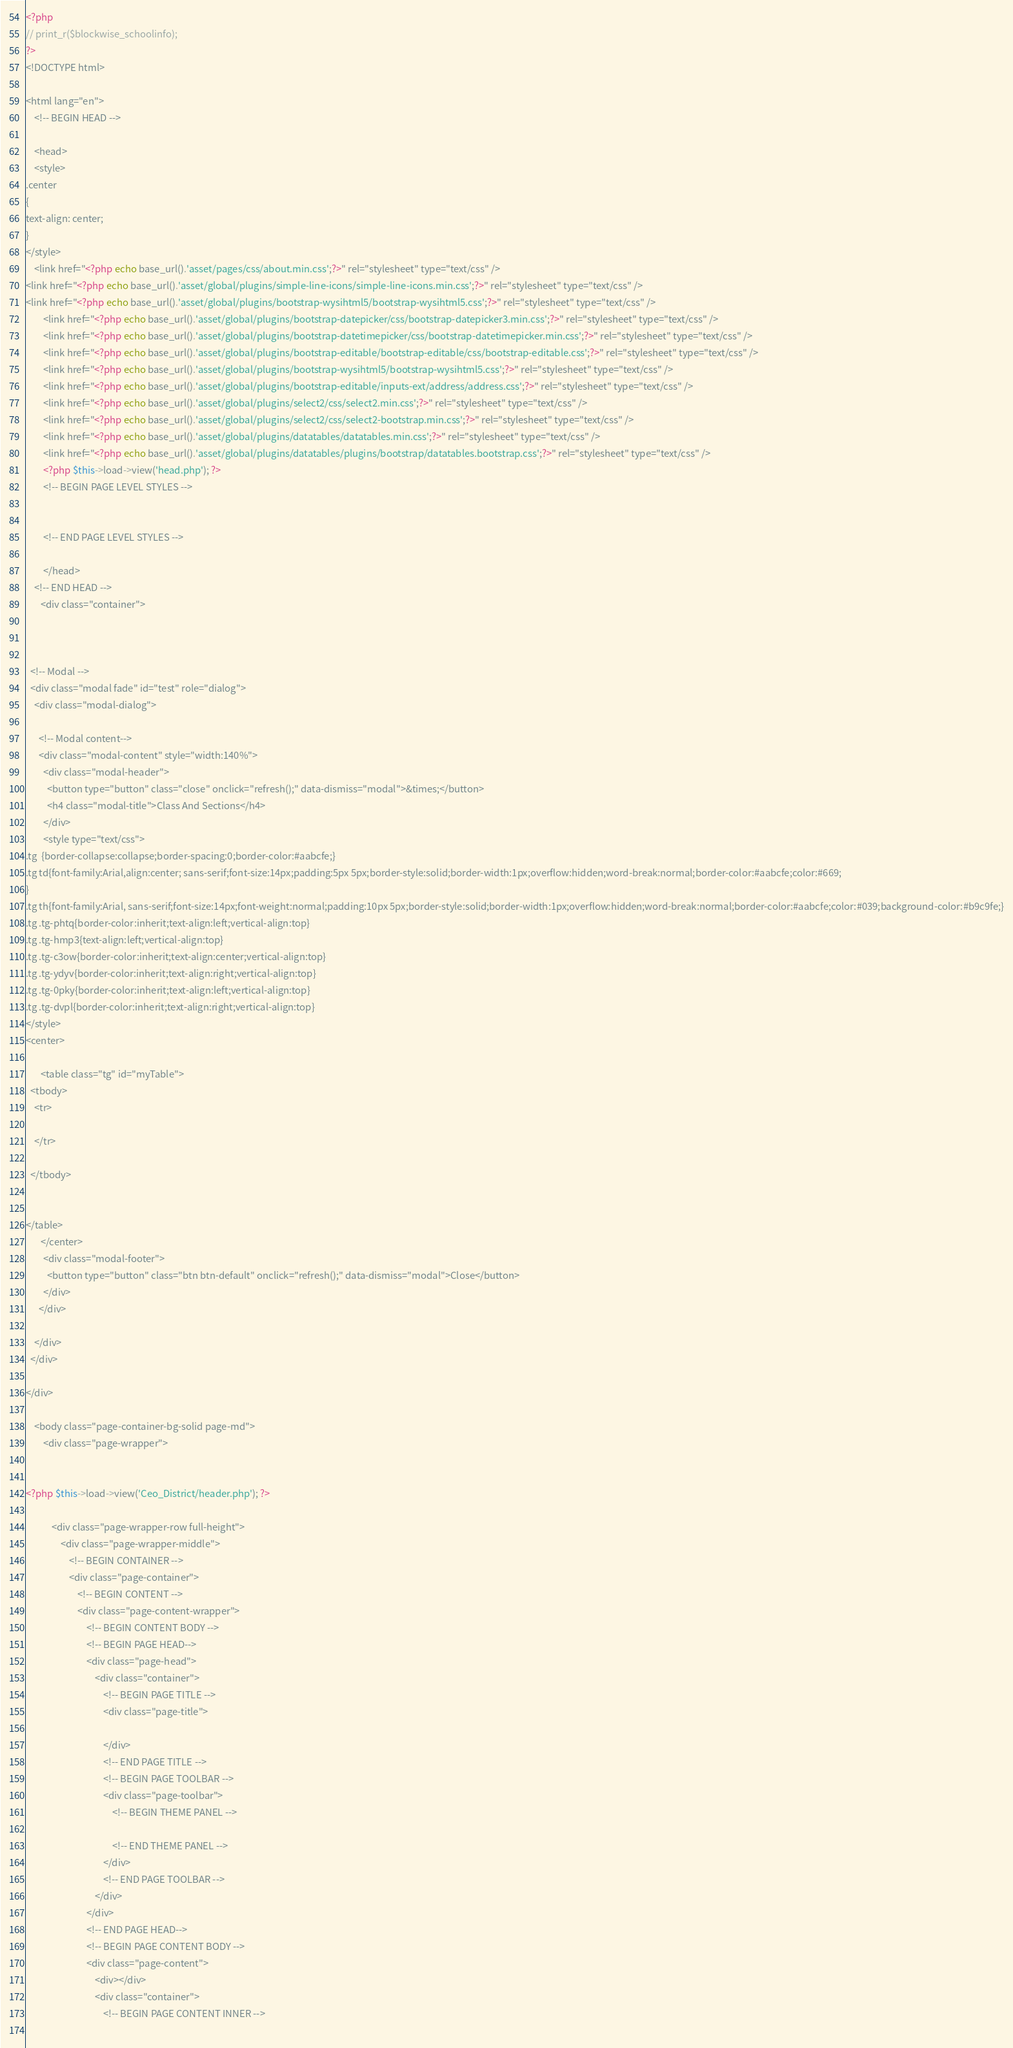Convert code to text. <code><loc_0><loc_0><loc_500><loc_500><_PHP_>

<?php 
// print_r($blockwise_schoolinfo);
?>
<!DOCTYPE html>

<html lang="en">
    <!-- BEGIN HEAD -->

    <head>
    <style> 
.center 
{
text-align: center;
}   
</style>
    <link href="<?php echo base_url().'asset/pages/css/about.min.css';?>" rel="stylesheet" type="text/css" />
<link href="<?php echo base_url().'asset/global/plugins/simple-line-icons/simple-line-icons.min.css';?>" rel="stylesheet" type="text/css" />
<link href="<?php echo base_url().'asset/global/plugins/bootstrap-wysihtml5/bootstrap-wysihtml5.css';?>" rel="stylesheet" type="text/css" />
        <link href="<?php echo base_url().'asset/global/plugins/bootstrap-datepicker/css/bootstrap-datepicker3.min.css';?>" rel="stylesheet" type="text/css" />
        <link href="<?php echo base_url().'asset/global/plugins/bootstrap-datetimepicker/css/bootstrap-datetimepicker.min.css';?>" rel="stylesheet" type="text/css" />
        <link href="<?php echo base_url().'asset/global/plugins/bootstrap-editable/bootstrap-editable/css/bootstrap-editable.css';?>" rel="stylesheet" type="text/css" />
        <link href="<?php echo base_url().'asset/global/plugins/bootstrap-wysihtml5/bootstrap-wysihtml5.css';?>" rel="stylesheet" type="text/css" />
        <link href="<?php echo base_url().'asset/global/plugins/bootstrap-editable/inputs-ext/address/address.css';?>" rel="stylesheet" type="text/css" />
        <link href="<?php echo base_url().'asset/global/plugins/select2/css/select2.min.css';?>" rel="stylesheet" type="text/css" />
        <link href="<?php echo base_url().'asset/global/plugins/select2/css/select2-bootstrap.min.css';?>" rel="stylesheet" type="text/css" />
        <link href="<?php echo base_url().'asset/global/plugins/datatables/datatables.min.css';?>" rel="stylesheet" type="text/css" />
        <link href="<?php echo base_url().'asset/global/plugins/datatables/plugins/bootstrap/datatables.bootstrap.css';?>" rel="stylesheet" type="text/css" />
        <?php $this->load->view('head.php'); ?>
        <!-- BEGIN PAGE LEVEL STYLES -->
    
       
        <!-- END PAGE LEVEL STYLES -->

        </head>
    <!-- END HEAD -->
	   <div class="container">
   
 

  <!-- Modal -->
  <div class="modal fade" id="test" role="dialog">
    <div class="modal-dialog">
    
      <!-- Modal content-->
      <div class="modal-content" style="width:140%">
        <div class="modal-header">
          <button type="button" class="close" onclick="refresh();" data-dismiss="modal">&times;</button>
          <h4 class="modal-title">Class And Sections</h4>
        </div>
		<style type="text/css">
.tg  {border-collapse:collapse;border-spacing:0;border-color:#aabcfe;}
.tg td{font-family:Arial,align:center; sans-serif;font-size:14px;padding:5px 5px;border-style:solid;border-width:1px;overflow:hidden;word-break:normal;border-color:#aabcfe;color:#669;
}
.tg th{font-family:Arial, sans-serif;font-size:14px;font-weight:normal;padding:10px 5px;border-style:solid;border-width:1px;overflow:hidden;word-break:normal;border-color:#aabcfe;color:#039;background-color:#b9c9fe;}
.tg .tg-phtq{border-color:inherit;text-align:left;vertical-align:top}
.tg .tg-hmp3{text-align:left;vertical-align:top}
.tg .tg-c3ow{border-color:inherit;text-align:center;vertical-align:top}
.tg .tg-ydyv{border-color:inherit;text-align:right;vertical-align:top}
.tg .tg-0pky{border-color:inherit;text-align:left;vertical-align:top}
.tg .tg-dvpl{border-color:inherit;text-align:right;vertical-align:top}
</style>
<center>

       <table class="tg" id="myTable">
  <tbody>
    <tr>
     
    </tr>
	
  </tbody>
  
  
</table>
	   </center>
        <div class="modal-footer">
          <button type="button" class="btn btn-default" onclick="refresh();" data-dismiss="modal">Close</button>
        </div>
      </div>
      
    </div>
  </div>
  
</div>

    <body class="page-container-bg-solid page-md">
        <div class="page-wrapper">
            

<?php $this->load->view('Ceo_District/header.php'); ?>

            <div class="page-wrapper-row full-height">
                <div class="page-wrapper-middle">
                    <!-- BEGIN CONTAINER -->
                    <div class="page-container">
                        <!-- BEGIN CONTENT -->
                        <div class="page-content-wrapper">
                            <!-- BEGIN CONTENT BODY -->
                            <!-- BEGIN PAGE HEAD-->
                            <div class="page-head">
                                <div class="container">
                                    <!-- BEGIN PAGE TITLE -->
                                    <div class="page-title">
                                       
                                    </div>
                                    <!-- END PAGE TITLE -->
                                    <!-- BEGIN PAGE TOOLBAR -->
                                    <div class="page-toolbar">
                                        <!-- BEGIN THEME PANEL -->
                           
                                        <!-- END THEME PANEL -->
                                    </div>
                                    <!-- END PAGE TOOLBAR -->
                                </div>
                            </div>
                            <!-- END PAGE HEAD-->
                            <!-- BEGIN PAGE CONTENT BODY -->
                            <div class="page-content">
                                <div></div> 
                                <div class="container">
                                    <!-- BEGIN PAGE CONTENT INNER -->
                          
</code> 